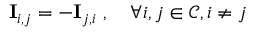Convert formula to latex. <formula><loc_0><loc_0><loc_500><loc_500>I _ { i , j } = - I _ { j , i } , \forall { i , j } \in \mathcal { C } , i \neq j</formula> 